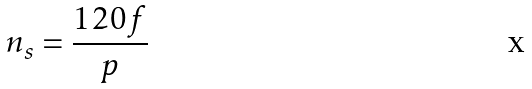Convert formula to latex. <formula><loc_0><loc_0><loc_500><loc_500>n _ { s } = \frac { 1 2 0 f } { p }</formula> 